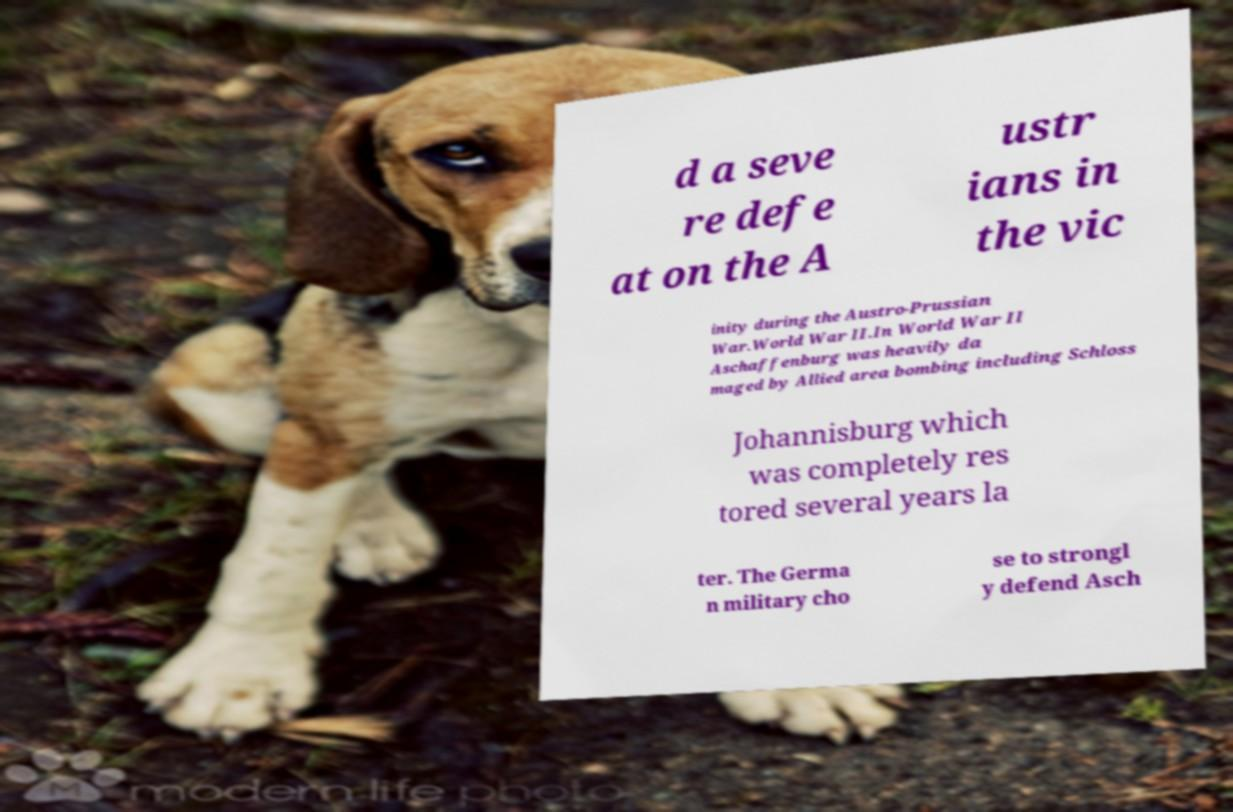Could you extract and type out the text from this image? d a seve re defe at on the A ustr ians in the vic inity during the Austro-Prussian War.World War II.In World War II Aschaffenburg was heavily da maged by Allied area bombing including Schloss Johannisburg which was completely res tored several years la ter. The Germa n military cho se to strongl y defend Asch 